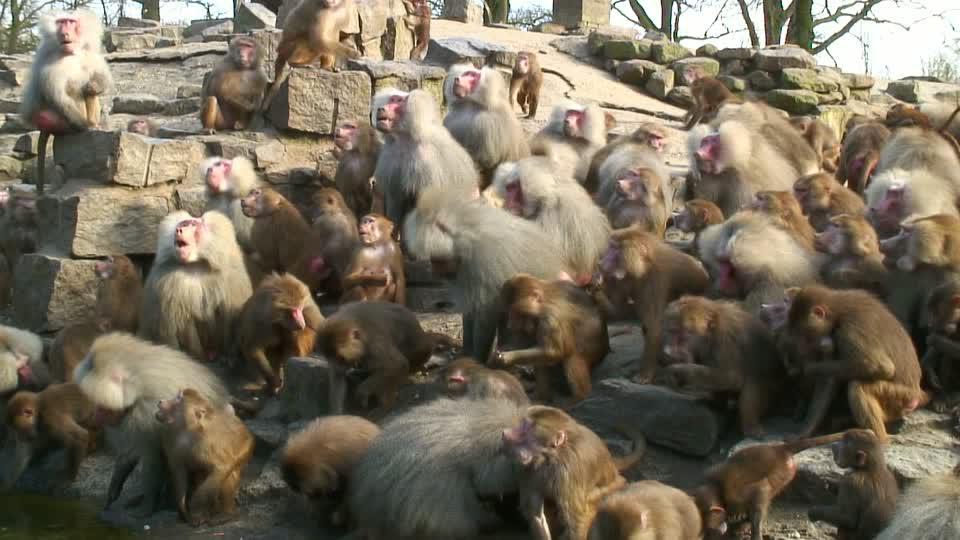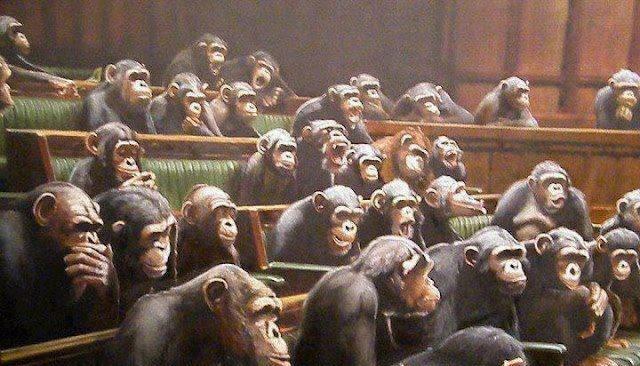The first image is the image on the left, the second image is the image on the right. For the images shown, is this caption "there are man made objects in the image on the left." true? Answer yes or no. No. 